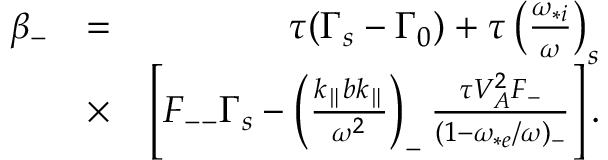Convert formula to latex. <formula><loc_0><loc_0><loc_500><loc_500>\begin{array} { r l r } { \beta _ { - } } & { = } & { \tau ( \Gamma _ { s } - \Gamma _ { 0 } ) + \tau \left ( \frac { \omega _ { * i } } { \omega } \right ) _ { s } } \\ & { \times } & { \left [ F _ { - - } \Gamma _ { s } - \left ( \frac { k _ { \| } b k _ { \| } } { \omega ^ { 2 } } \right ) _ { - } \frac { \tau V _ { A } ^ { 2 } F _ { - } } { ( 1 - \omega _ { * e } / \omega ) _ { - } } \right ] . } \end{array}</formula> 